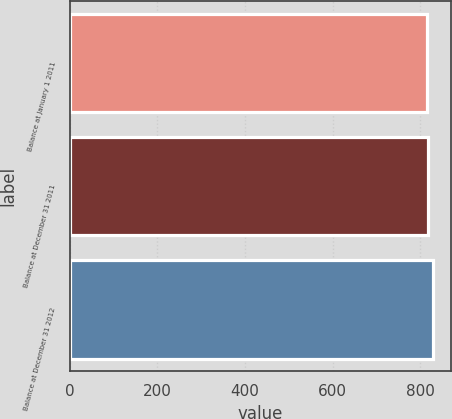Convert chart to OTSL. <chart><loc_0><loc_0><loc_500><loc_500><bar_chart><fcel>Balance at January 1 2011<fcel>Balance at December 31 2011<fcel>Balance at December 31 2012<nl><fcel>815<fcel>818<fcel>830<nl></chart> 